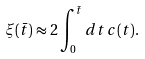<formula> <loc_0><loc_0><loc_500><loc_500>\xi ( { \bar { t } } ) \approx 2 \int ^ { \bar { t } } _ { 0 } d t \, c ( t ) .</formula> 